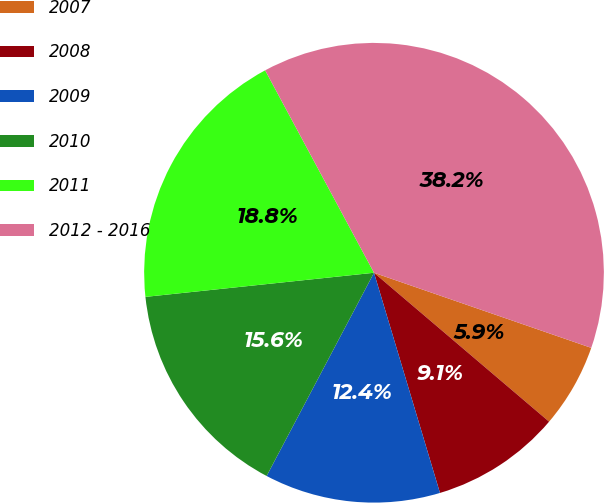<chart> <loc_0><loc_0><loc_500><loc_500><pie_chart><fcel>2007<fcel>2008<fcel>2009<fcel>2010<fcel>2011<fcel>2012 - 2016<nl><fcel>5.92%<fcel>9.15%<fcel>12.37%<fcel>15.59%<fcel>18.82%<fcel>38.15%<nl></chart> 